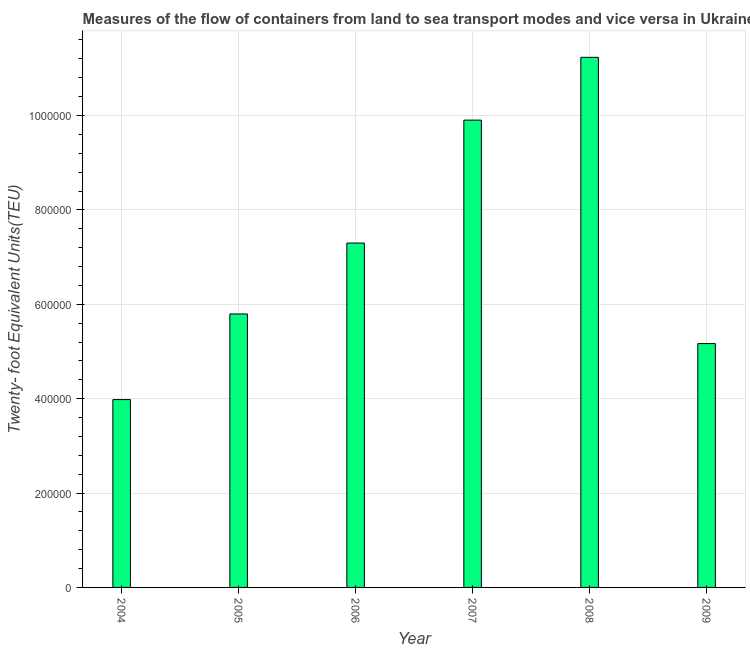Does the graph contain grids?
Give a very brief answer. Yes. What is the title of the graph?
Your answer should be very brief. Measures of the flow of containers from land to sea transport modes and vice versa in Ukraine. What is the label or title of the X-axis?
Make the answer very short. Year. What is the label or title of the Y-axis?
Offer a terse response. Twenty- foot Equivalent Units(TEU). What is the container port traffic in 2005?
Keep it short and to the point. 5.79e+05. Across all years, what is the maximum container port traffic?
Ensure brevity in your answer.  1.12e+06. Across all years, what is the minimum container port traffic?
Ensure brevity in your answer.  3.98e+05. In which year was the container port traffic maximum?
Give a very brief answer. 2008. What is the sum of the container port traffic?
Offer a terse response. 4.34e+06. What is the difference between the container port traffic in 2005 and 2007?
Your response must be concise. -4.11e+05. What is the average container port traffic per year?
Make the answer very short. 7.23e+05. What is the median container port traffic?
Offer a very short reply. 6.55e+05. In how many years, is the container port traffic greater than 80000 TEU?
Your answer should be very brief. 6. What is the ratio of the container port traffic in 2004 to that in 2009?
Your answer should be very brief. 0.77. What is the difference between the highest and the second highest container port traffic?
Offer a very short reply. 1.33e+05. Is the sum of the container port traffic in 2006 and 2008 greater than the maximum container port traffic across all years?
Keep it short and to the point. Yes. What is the difference between the highest and the lowest container port traffic?
Give a very brief answer. 7.25e+05. What is the difference between two consecutive major ticks on the Y-axis?
Make the answer very short. 2.00e+05. Are the values on the major ticks of Y-axis written in scientific E-notation?
Provide a short and direct response. No. What is the Twenty- foot Equivalent Units(TEU) of 2004?
Offer a very short reply. 3.98e+05. What is the Twenty- foot Equivalent Units(TEU) of 2005?
Make the answer very short. 5.79e+05. What is the Twenty- foot Equivalent Units(TEU) of 2006?
Offer a very short reply. 7.30e+05. What is the Twenty- foot Equivalent Units(TEU) of 2007?
Your answer should be very brief. 9.90e+05. What is the Twenty- foot Equivalent Units(TEU) of 2008?
Offer a very short reply. 1.12e+06. What is the Twenty- foot Equivalent Units(TEU) of 2009?
Offer a terse response. 5.17e+05. What is the difference between the Twenty- foot Equivalent Units(TEU) in 2004 and 2005?
Provide a succinct answer. -1.81e+05. What is the difference between the Twenty- foot Equivalent Units(TEU) in 2004 and 2006?
Provide a succinct answer. -3.32e+05. What is the difference between the Twenty- foot Equivalent Units(TEU) in 2004 and 2007?
Your answer should be very brief. -5.92e+05. What is the difference between the Twenty- foot Equivalent Units(TEU) in 2004 and 2008?
Make the answer very short. -7.25e+05. What is the difference between the Twenty- foot Equivalent Units(TEU) in 2004 and 2009?
Offer a terse response. -1.19e+05. What is the difference between the Twenty- foot Equivalent Units(TEU) in 2005 and 2006?
Offer a very short reply. -1.50e+05. What is the difference between the Twenty- foot Equivalent Units(TEU) in 2005 and 2007?
Give a very brief answer. -4.11e+05. What is the difference between the Twenty- foot Equivalent Units(TEU) in 2005 and 2008?
Your answer should be very brief. -5.44e+05. What is the difference between the Twenty- foot Equivalent Units(TEU) in 2005 and 2009?
Give a very brief answer. 6.28e+04. What is the difference between the Twenty- foot Equivalent Units(TEU) in 2006 and 2007?
Ensure brevity in your answer.  -2.60e+05. What is the difference between the Twenty- foot Equivalent Units(TEU) in 2006 and 2008?
Provide a short and direct response. -3.94e+05. What is the difference between the Twenty- foot Equivalent Units(TEU) in 2006 and 2009?
Your answer should be very brief. 2.13e+05. What is the difference between the Twenty- foot Equivalent Units(TEU) in 2007 and 2008?
Offer a terse response. -1.33e+05. What is the difference between the Twenty- foot Equivalent Units(TEU) in 2007 and 2009?
Offer a very short reply. 4.74e+05. What is the difference between the Twenty- foot Equivalent Units(TEU) in 2008 and 2009?
Your answer should be compact. 6.07e+05. What is the ratio of the Twenty- foot Equivalent Units(TEU) in 2004 to that in 2005?
Offer a terse response. 0.69. What is the ratio of the Twenty- foot Equivalent Units(TEU) in 2004 to that in 2006?
Keep it short and to the point. 0.55. What is the ratio of the Twenty- foot Equivalent Units(TEU) in 2004 to that in 2007?
Make the answer very short. 0.4. What is the ratio of the Twenty- foot Equivalent Units(TEU) in 2004 to that in 2008?
Ensure brevity in your answer.  0.35. What is the ratio of the Twenty- foot Equivalent Units(TEU) in 2004 to that in 2009?
Provide a succinct answer. 0.77. What is the ratio of the Twenty- foot Equivalent Units(TEU) in 2005 to that in 2006?
Ensure brevity in your answer.  0.79. What is the ratio of the Twenty- foot Equivalent Units(TEU) in 2005 to that in 2007?
Keep it short and to the point. 0.58. What is the ratio of the Twenty- foot Equivalent Units(TEU) in 2005 to that in 2008?
Keep it short and to the point. 0.52. What is the ratio of the Twenty- foot Equivalent Units(TEU) in 2005 to that in 2009?
Give a very brief answer. 1.12. What is the ratio of the Twenty- foot Equivalent Units(TEU) in 2006 to that in 2007?
Give a very brief answer. 0.74. What is the ratio of the Twenty- foot Equivalent Units(TEU) in 2006 to that in 2008?
Provide a short and direct response. 0.65. What is the ratio of the Twenty- foot Equivalent Units(TEU) in 2006 to that in 2009?
Keep it short and to the point. 1.41. What is the ratio of the Twenty- foot Equivalent Units(TEU) in 2007 to that in 2008?
Provide a short and direct response. 0.88. What is the ratio of the Twenty- foot Equivalent Units(TEU) in 2007 to that in 2009?
Make the answer very short. 1.92. What is the ratio of the Twenty- foot Equivalent Units(TEU) in 2008 to that in 2009?
Offer a very short reply. 2.17. 